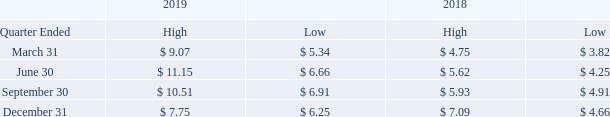Item 5. Market for Registrant’s Common Equity, Related Stockholder Matters and Issuer Purchases of Equity Securities
Our common stock trades on The Nasdaq Stock Market under the symbol ZIXI. The table below shows the high and low sales prices by quarter for fiscal 2019 and 2018.
At March 4, 2020, there were 55,641,885 shares of common stock outstanding held by 399 shareholders of record. On that date, the last reported sales price of the common stock was $8.27.
We have not paid any cash dividends on our common stock and do not anticipate doing so in the foreseeable future.
For information regarding options and stock-based compensation awards outstanding and available for future grants, see “Item 12. Security Ownership of Certain Beneficial Owners and Management and Related Stockholder Matters.”
What was the high and low value for ZIXI for the quarter ended March 31 2019? 9.07, 5.34. How many shares of common stock are there outstanding as at March 4, 2020? 55,641,885. Where can one find information on options and stock-based compensation awards outstanding and available for future grants? Item 12. security ownership of certain beneficial owners and management and related stockholder matters. What is the average number of shares of common stock outstanding held by each shareholder as of March 4 2020? 55,641,885/399
Answer: 139453.35. What is the average low sale prices for the year 2019? (5.34+6.66+6.91+6.25)/4
Answer: 6.29. What was the change in high value for the quarter ended september 30 in 2019 than 2018? 10.51-5.93
Answer: 4.58. 